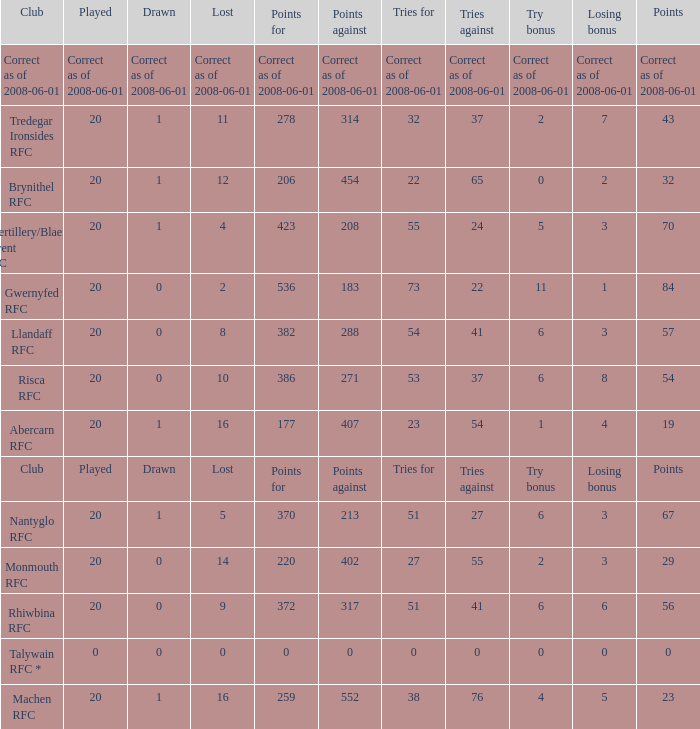Name the tries when tries against were 41, try bonus was 6, and had 317 points. 51.0. 